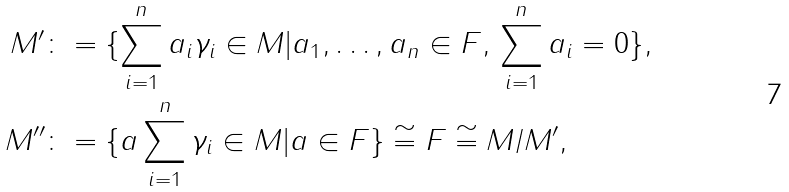<formula> <loc_0><loc_0><loc_500><loc_500>M ^ { \prime } & \colon = \{ \sum _ { i = 1 } ^ { n } a _ { i } \gamma _ { i } \in M | a _ { 1 } , \dots , a _ { n } \in F , \, \sum _ { i = 1 } ^ { n } a _ { i } = 0 \} , \\ M ^ { \prime \prime } & \colon = \{ a \sum _ { i = 1 } ^ { n } \gamma _ { i } \in M | a \in F \} \cong F \cong M / M ^ { \prime } ,</formula> 